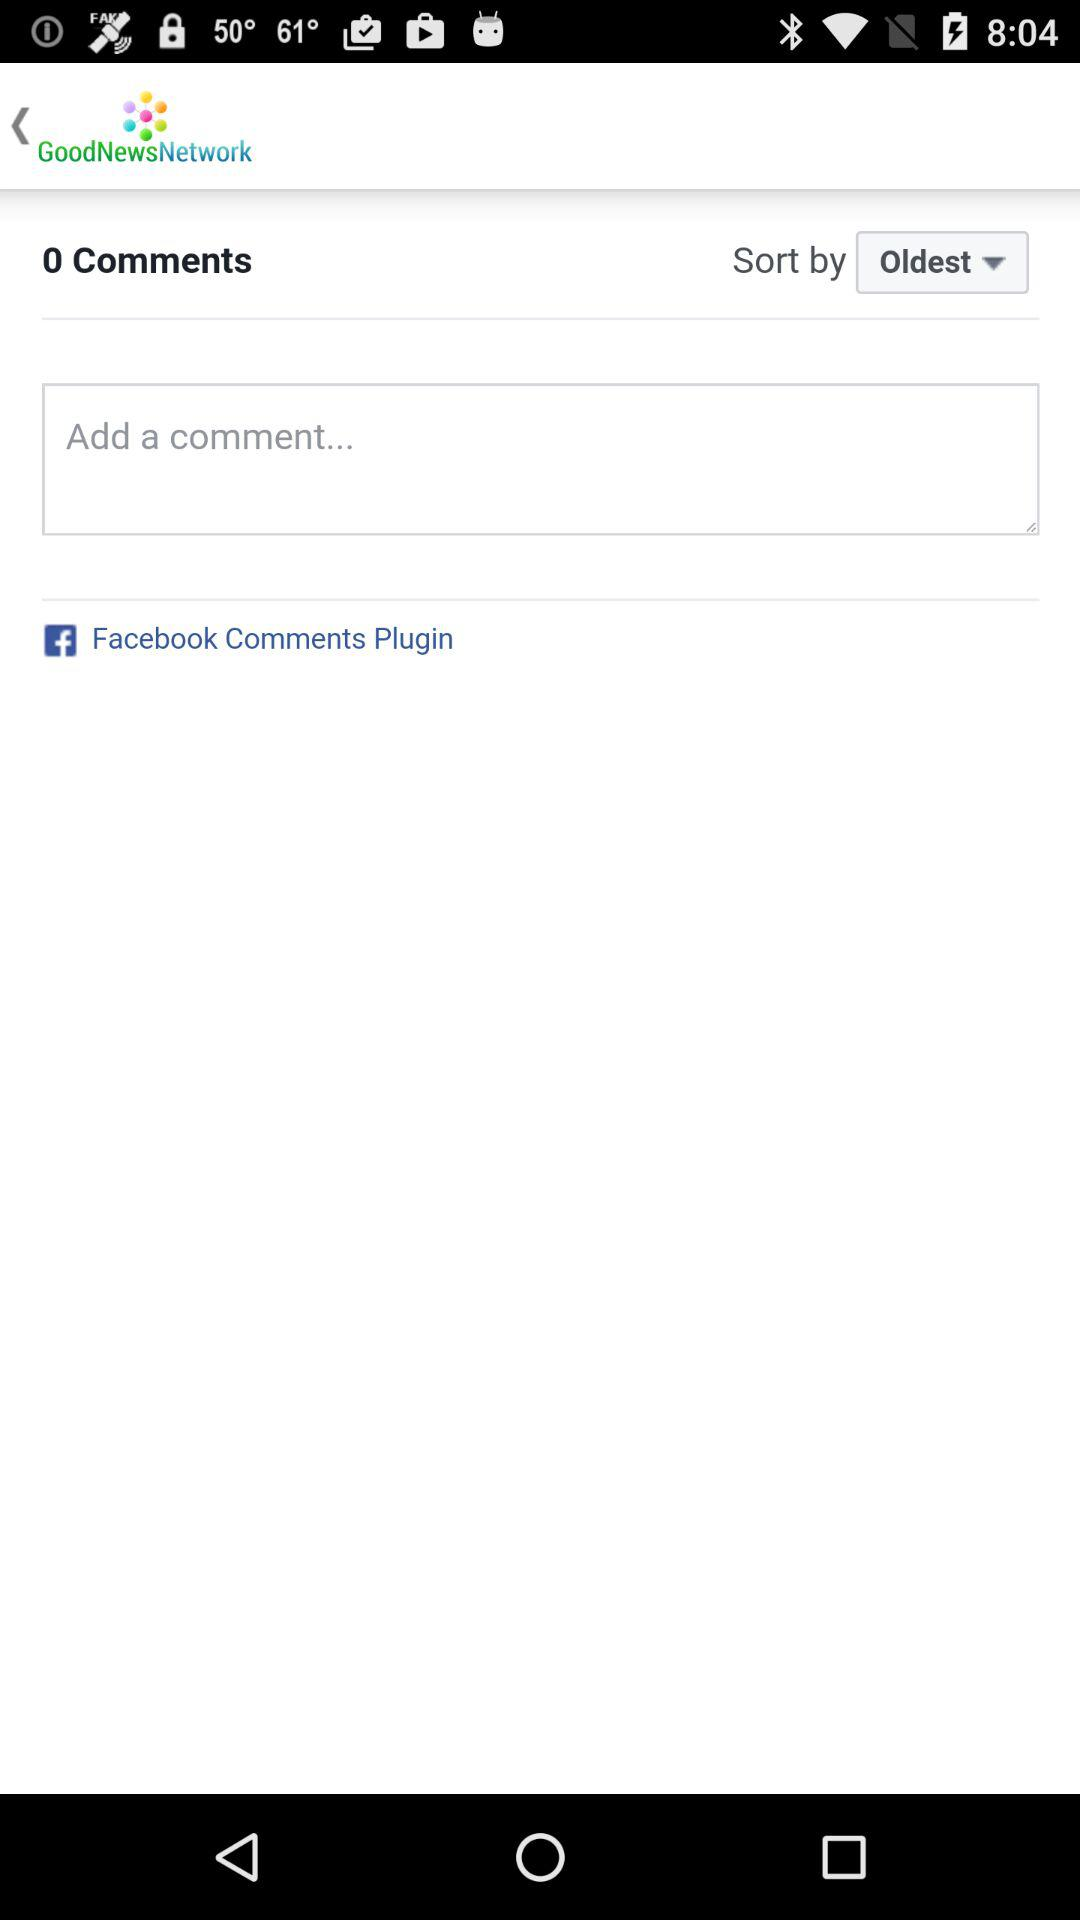How many comments are there? There are 0 comments. 